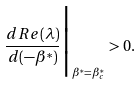Convert formula to latex. <formula><loc_0><loc_0><loc_500><loc_500>\frac { d R e ( \lambda ) } { d ( - \beta ^ { * } ) } \Big | _ { \beta ^ { * } = \beta ^ { * } _ { c } } > 0 .</formula> 